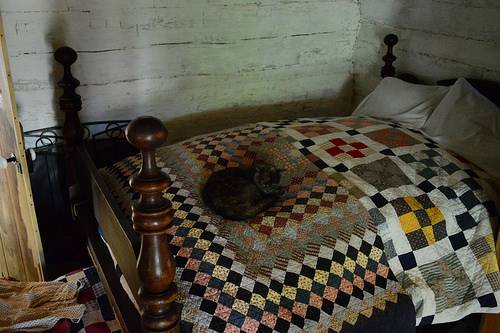<image>
Is there a bed under the cat? Yes. The bed is positioned underneath the cat, with the cat above it in the vertical space. 